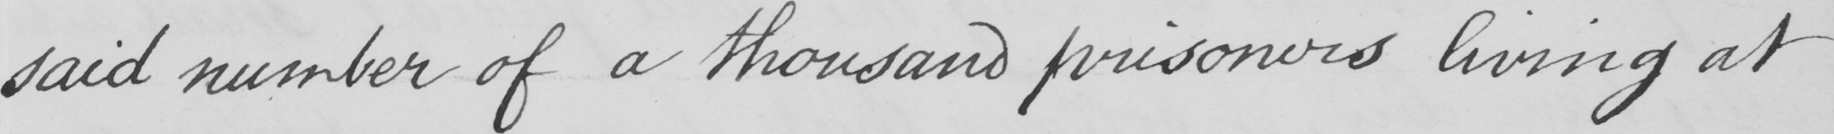What does this handwritten line say? said number of a thousand prisoners living at 